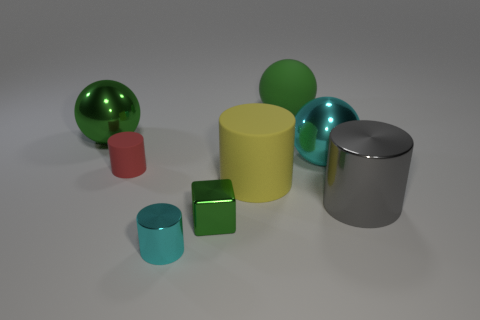There is a cyan thing that is in front of the cyan sphere; what is its material?
Offer a terse response. Metal. What size is the green rubber thing?
Your response must be concise. Large. How many blue objects are small metal objects or metal balls?
Give a very brief answer. 0. How big is the cyan metal thing behind the red cylinder behind the large yellow cylinder?
Ensure brevity in your answer.  Large. Do the large matte ball and the matte cylinder that is on the right side of the small red object have the same color?
Offer a very short reply. No. What number of other things are the same material as the big gray thing?
Keep it short and to the point. 4. What is the shape of the large yellow thing that is made of the same material as the red thing?
Give a very brief answer. Cylinder. Is there any other thing that is the same color as the tiny block?
Provide a succinct answer. Yes. What size is the object that is the same color as the tiny metal cylinder?
Give a very brief answer. Large. Are there more tiny cyan objects that are behind the big gray metallic cylinder than tiny red matte cylinders?
Your answer should be very brief. No. 